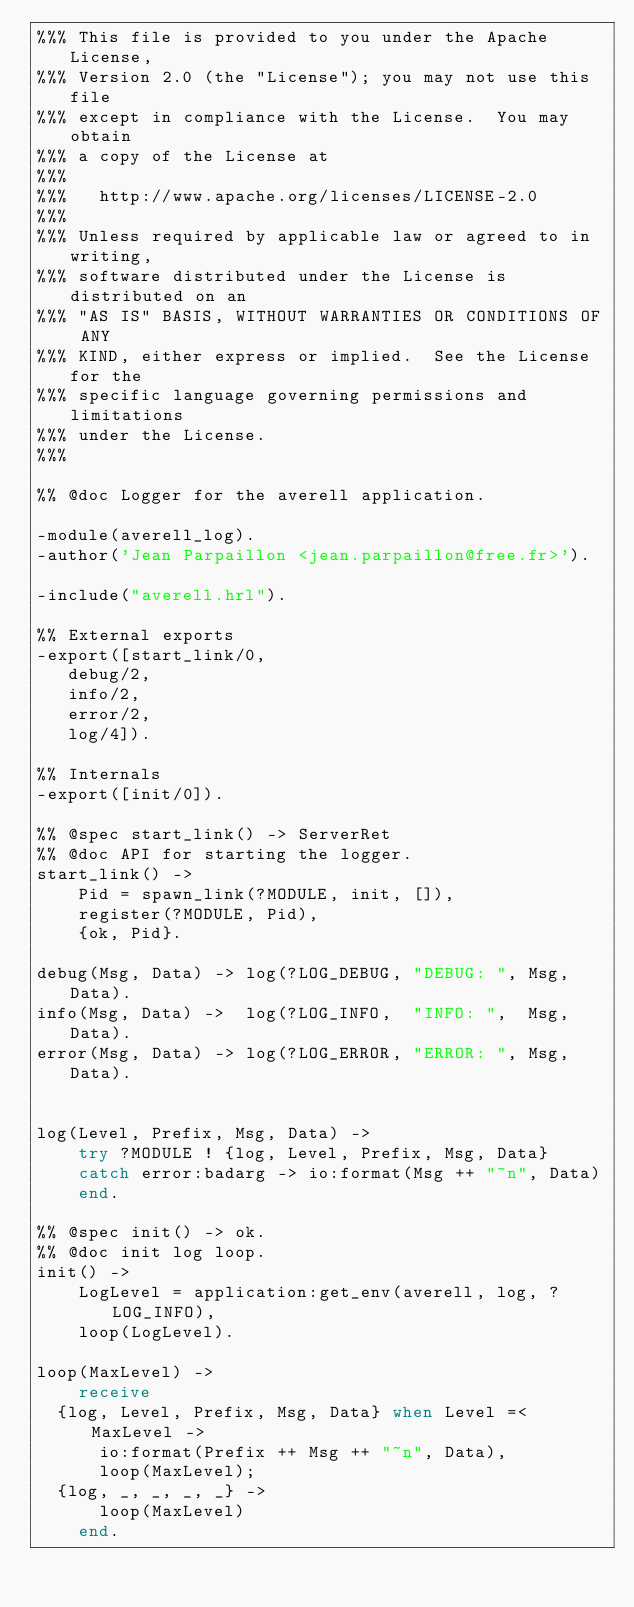<code> <loc_0><loc_0><loc_500><loc_500><_Erlang_>%%% This file is provided to you under the Apache License,
%%% Version 2.0 (the "License"); you may not use this file
%%% except in compliance with the License.  You may obtain
%%% a copy of the License at
%%% 
%%%   http://www.apache.org/licenses/LICENSE-2.0
%%% 
%%% Unless required by applicable law or agreed to in writing,
%%% software distributed under the License is distributed on an
%%% "AS IS" BASIS, WITHOUT WARRANTIES OR CONDITIONS OF ANY
%%% KIND, either express or implied.  See the License for the
%%% specific language governing permissions and limitations
%%% under the License.
%%% 

%% @doc Logger for the averell application.

-module(averell_log).
-author('Jean Parpaillon <jean.parpaillon@free.fr>').

-include("averell.hrl").

%% External exports
-export([start_link/0,
	 debug/2,
	 info/2,
	 error/2,
	 log/4]).

%% Internals
-export([init/0]).

%% @spec start_link() -> ServerRet
%% @doc API for starting the logger.
start_link() ->
    Pid = spawn_link(?MODULE, init, []),
    register(?MODULE, Pid),
    {ok, Pid}.

debug(Msg, Data) -> log(?LOG_DEBUG, "DEBUG: ", Msg, Data).
info(Msg, Data) ->  log(?LOG_INFO,  "INFO: ",  Msg, Data).
error(Msg, Data) -> log(?LOG_ERROR, "ERROR: ", Msg, Data).


log(Level, Prefix, Msg, Data) ->
    try ?MODULE ! {log, Level, Prefix, Msg, Data}
    catch error:badarg -> io:format(Msg ++ "~n", Data)
    end.

%% @spec init() -> ok.
%% @doc init log loop.
init() ->
    LogLevel = application:get_env(averell, log, ?LOG_INFO),
    loop(LogLevel).

loop(MaxLevel) ->
    receive
	{log, Level, Prefix, Msg, Data} when Level =< MaxLevel ->
	    io:format(Prefix ++ Msg ++ "~n", Data),
	    loop(MaxLevel);
	{log, _, _, _, _} -> 
	    loop(MaxLevel)
    end.
</code> 